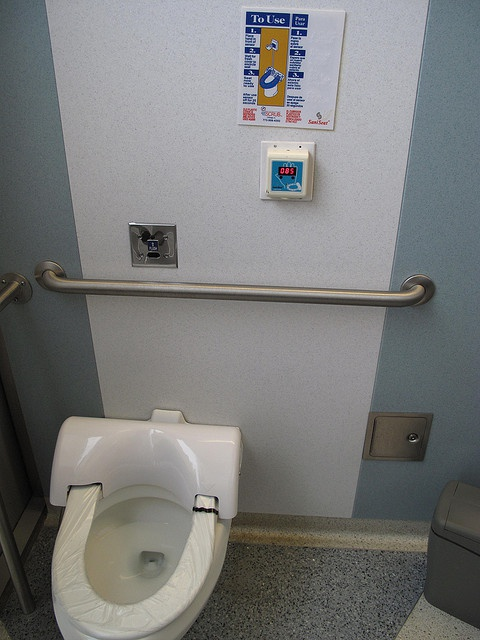Describe the objects in this image and their specific colors. I can see a toilet in purple, darkgray, gray, and lightgray tones in this image. 